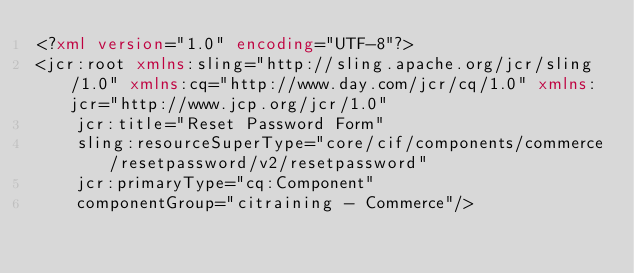Convert code to text. <code><loc_0><loc_0><loc_500><loc_500><_XML_><?xml version="1.0" encoding="UTF-8"?>
<jcr:root xmlns:sling="http://sling.apache.org/jcr/sling/1.0" xmlns:cq="http://www.day.com/jcr/cq/1.0" xmlns:jcr="http://www.jcp.org/jcr/1.0"
    jcr:title="Reset Password Form"
    sling:resourceSuperType="core/cif/components/commerce/resetpassword/v2/resetpassword"
    jcr:primaryType="cq:Component"
    componentGroup="citraining - Commerce"/></code> 